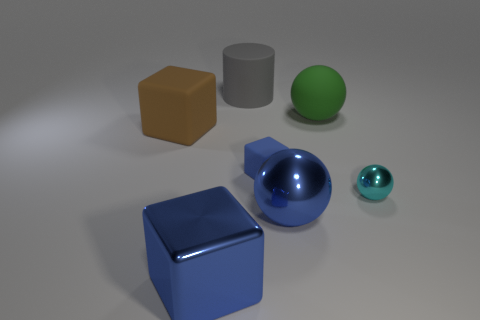Subtract all large spheres. How many spheres are left? 1 Subtract 1 cylinders. How many cylinders are left? 0 Subtract all green balls. How many balls are left? 2 Add 3 small blocks. How many objects exist? 10 Subtract all spheres. How many objects are left? 4 Subtract all cyan balls. Subtract all cyan cubes. How many balls are left? 2 Subtract all brown blocks. How many cyan spheres are left? 1 Subtract all small yellow rubber spheres. Subtract all blue spheres. How many objects are left? 6 Add 4 big brown matte cubes. How many big brown matte cubes are left? 5 Add 7 small cyan metal things. How many small cyan metal things exist? 8 